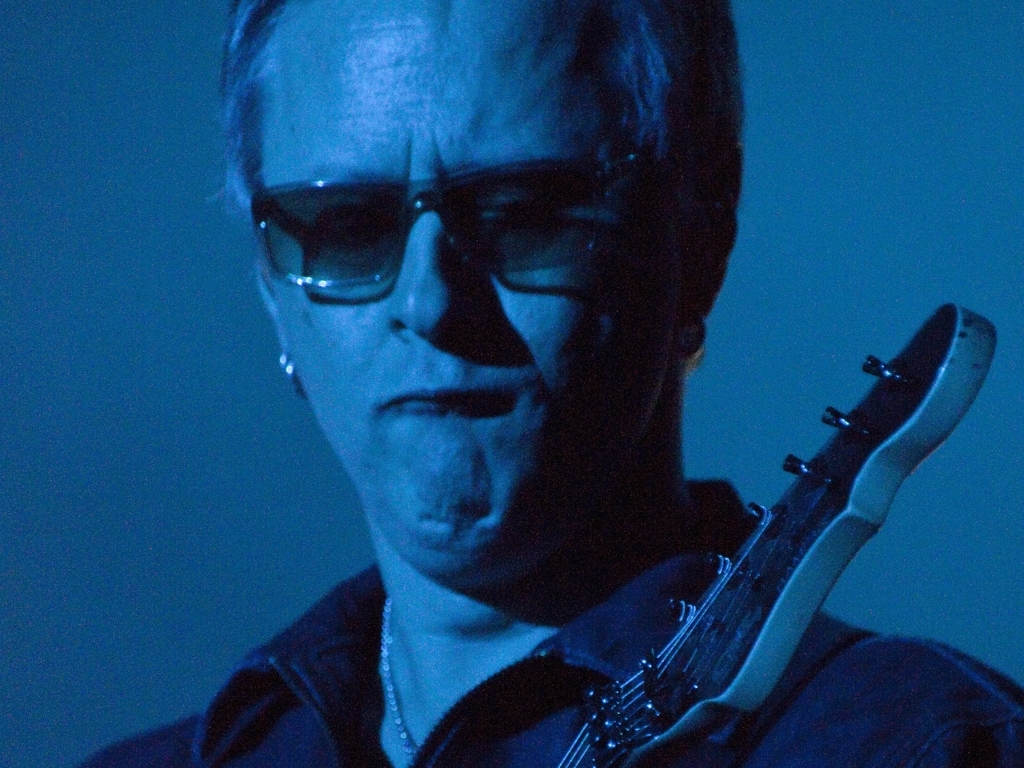Can you describe the person seen in this image? The image features a person who appears to be a male, wearing sunglasses and playing an electric guitar. The ambient lighting is dim and predominantly blue, providing a moody atmosphere. The photo's focus is fairly centered on him, enhancing his prominence in the shot. 